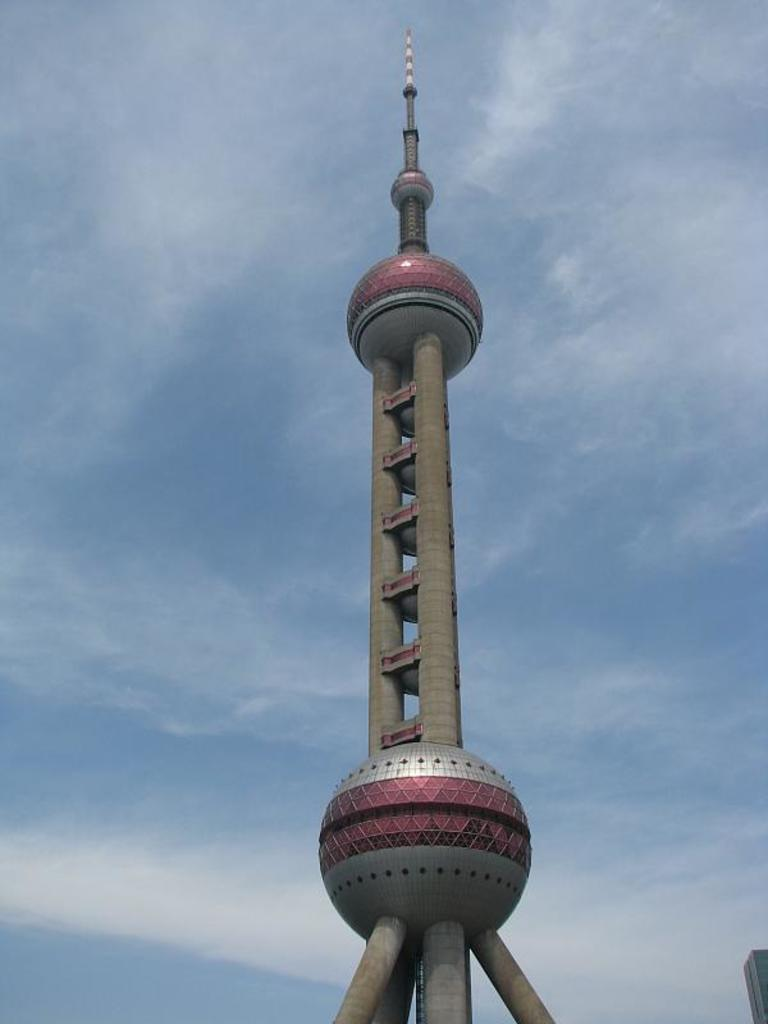What is the main structure visible in the image? There is a tower in the image. What is visible in the background of the image? The sky is visible in the background of the image. What can be seen in the sky in the background of the image? Clouds are present in the sky in the background of the image. How many steps does it take to reach the top of the tower in the image? The image does not provide information about the number of steps to reach the top of the tower. Are there any bears visible in the image? There are no bears present in the image. 